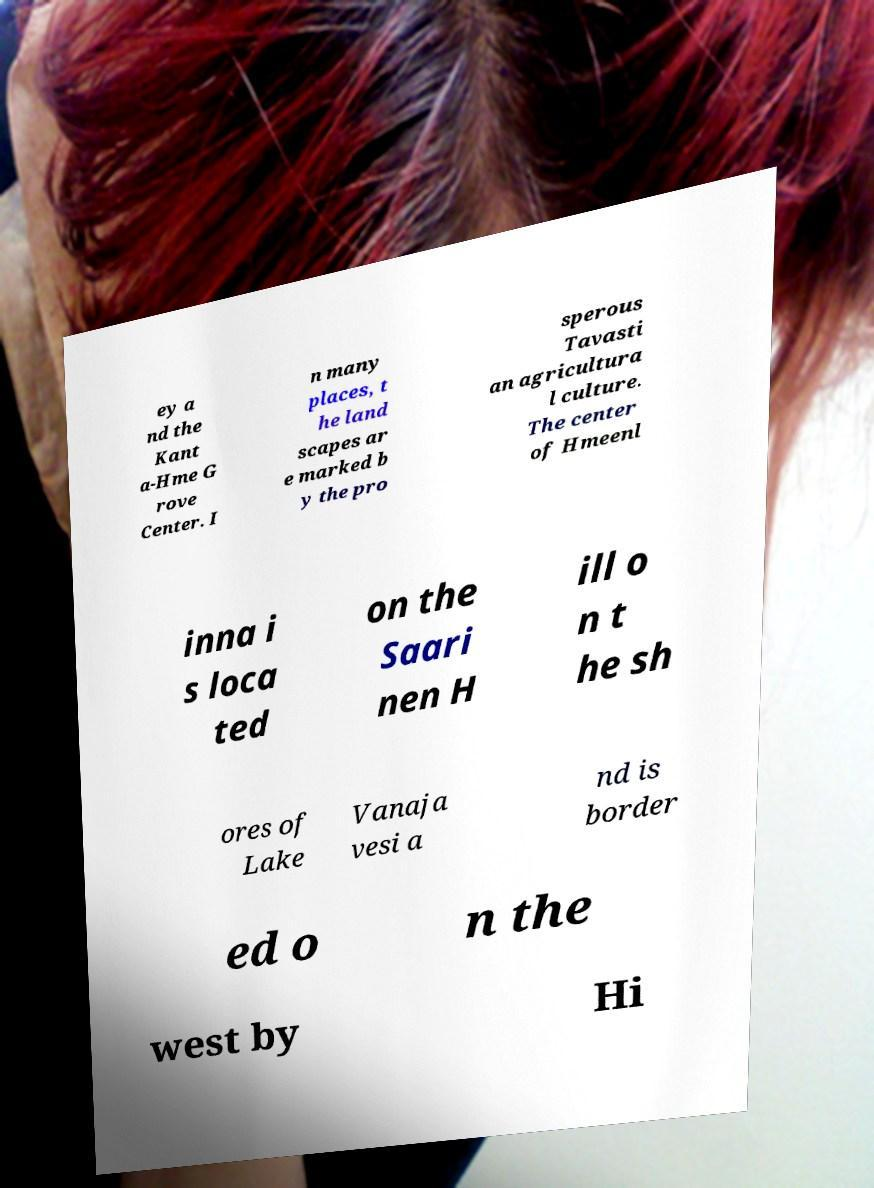Could you assist in decoding the text presented in this image and type it out clearly? ey a nd the Kant a-Hme G rove Center. I n many places, t he land scapes ar e marked b y the pro sperous Tavasti an agricultura l culture. The center of Hmeenl inna i s loca ted on the Saari nen H ill o n t he sh ores of Lake Vanaja vesi a nd is border ed o n the west by Hi 